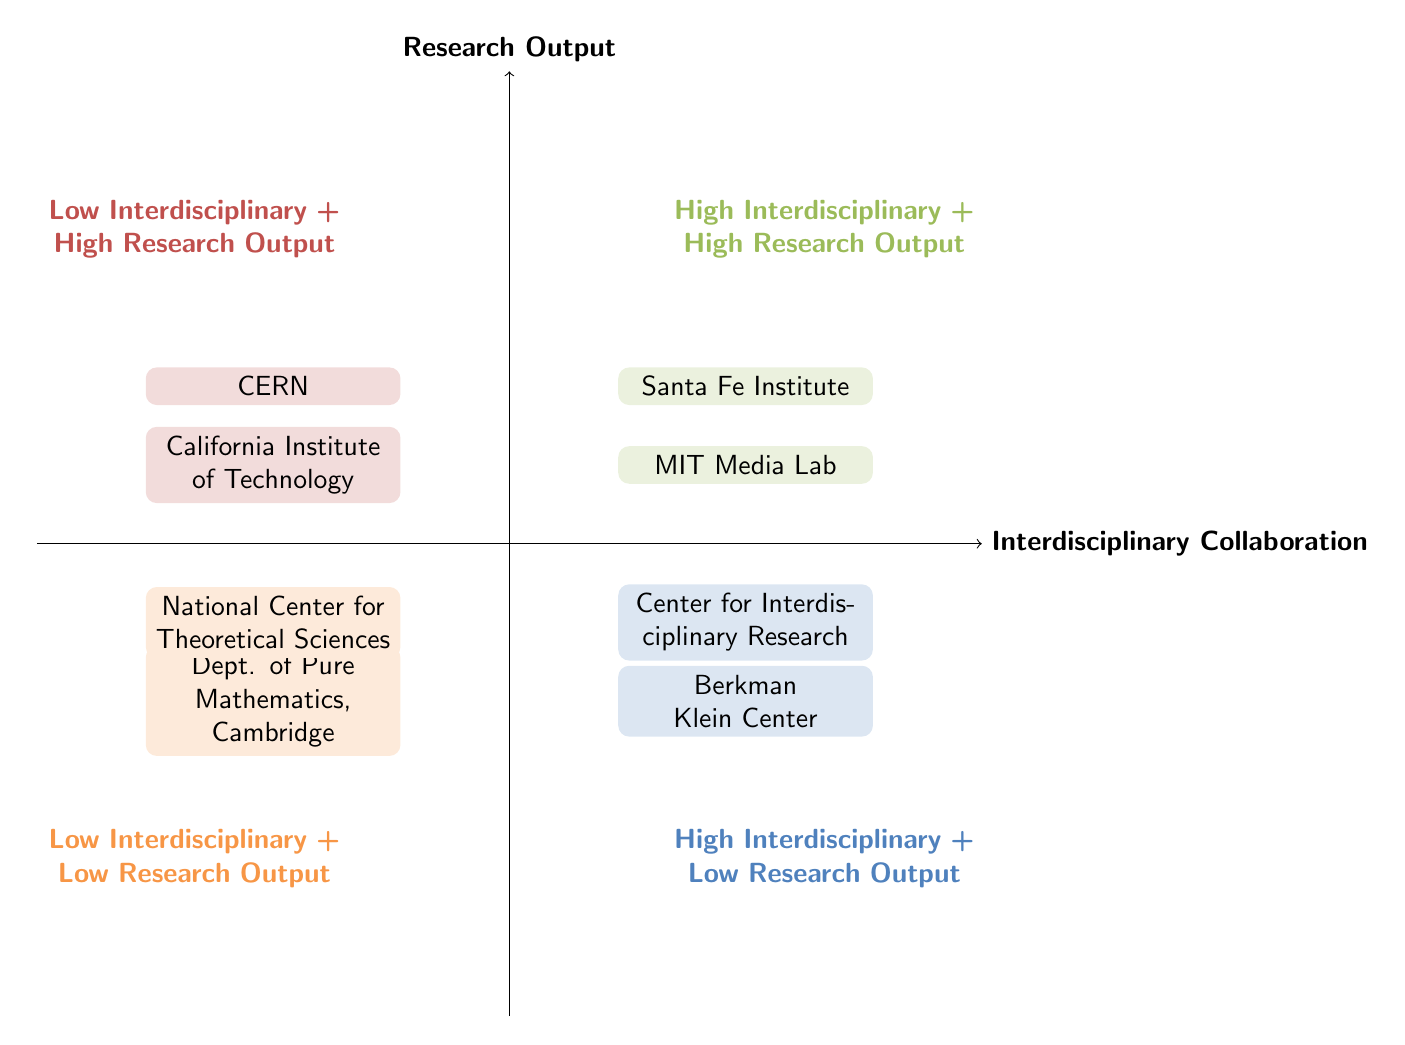What institutions are in the High Interdisciplinary + High Research Output quadrant? The diagram shows that the institutions in this quadrant are Santa Fe Institute and MIT Media Lab.
Answer: Santa Fe Institute, MIT Media Lab Which quadrant contains CERN? By checking the quadrants, CERN is located in the Low Interdisciplinary + High Research Output quadrant.
Answer: Low Interdisciplinary + High Research Output How many institutions are categorized under Low Interdisciplinary + Low Research Output? The diagram shows two institutions in this quadrant: Department of Pure Mathematics, University of Cambridge and National Center for Theoretical Sciences, which totals to two.
Answer: 2 What is the distinguishing feature of the High Interdisciplinary + Low Research Output quadrant? The unique characteristic of this quadrant is that it involves institutions with high interdisciplinary collaboration but low research output, as seen with the Berkman Klein Center and Center for Interdisciplinary Research.
Answer: High interdisciplinary collaboration Name one institution from the Low Interdisciplinary + High Research Output quadrant. The diagram specifically lists CERN and California Institute of Technology as institutions in this quadrant, either can be mentioned.
Answer: CERN In which quadrant does the Center for Interdisciplinary Research fall? The diagram places the Center for Interdisciplinary Research in the High Interdisciplinary + Low Research Output quadrant.
Answer: High Interdisciplinary + Low Research Output Which quadrant has the highest research output? The quadrants can be compared, and it is clear that both High Interdisciplinary + High Research Output and Low Interdisciplinary + High Research Output quadrants show the highest research output level.
Answer: High Interdisciplinary + High Research Output, Low Interdisciplinary + High Research Output What quadrant do institutions with low research outputs share? Analyzing the diagram, the two quadrants with low research outputs are High Interdisciplinary + Low Research Output and Low Interdisciplinary + Low Research Output.
Answer: High Interdisciplinary + Low Research Output, Low Interdisciplinary + Low Research Output 